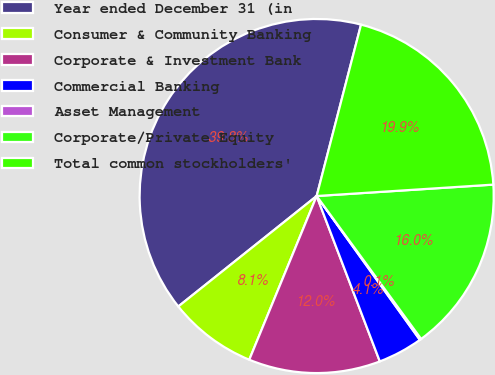Convert chart. <chart><loc_0><loc_0><loc_500><loc_500><pie_chart><fcel>Year ended December 31 (in<fcel>Consumer & Community Banking<fcel>Corporate & Investment Bank<fcel>Commercial Banking<fcel>Asset Management<fcel>Corporate/Private Equity<fcel>Total common stockholders'<nl><fcel>39.75%<fcel>8.06%<fcel>12.02%<fcel>4.1%<fcel>0.14%<fcel>15.98%<fcel>19.94%<nl></chart> 